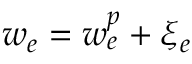<formula> <loc_0><loc_0><loc_500><loc_500>w _ { e } = w _ { e } ^ { p } + \xi _ { e }</formula> 